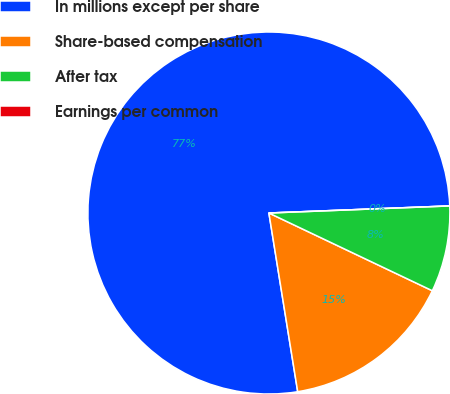Convert chart. <chart><loc_0><loc_0><loc_500><loc_500><pie_chart><fcel>In millions except per share<fcel>Share-based compensation<fcel>After tax<fcel>Earnings per common<nl><fcel>76.92%<fcel>15.39%<fcel>7.69%<fcel>0.0%<nl></chart> 